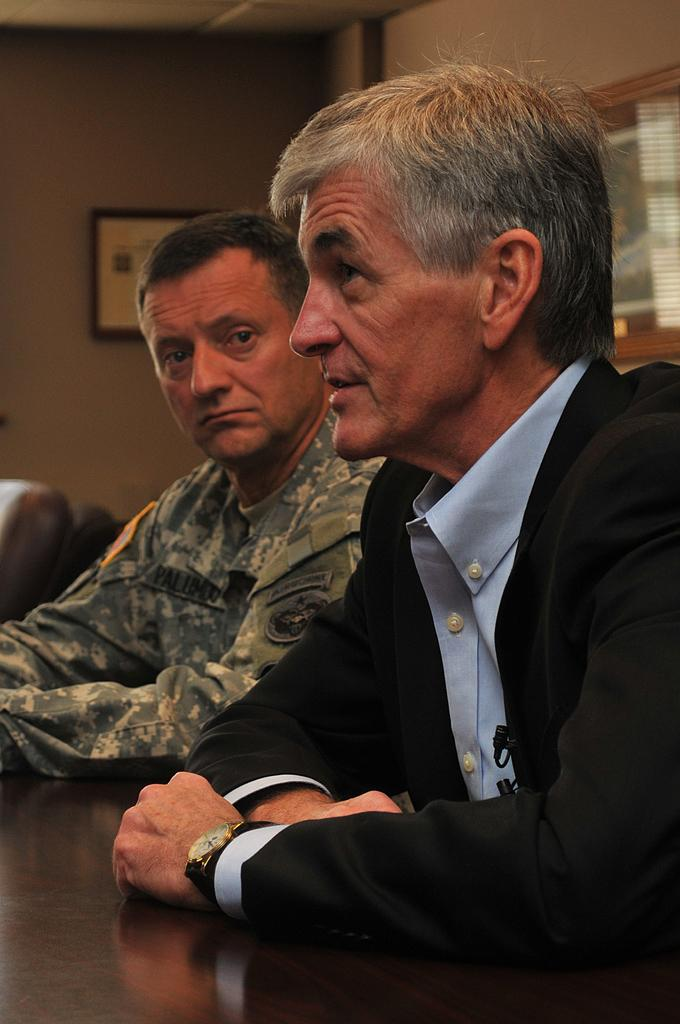How many people are in the image? There are two people in the image. What is the position of the person on the right side? The person on the right side is sitting. What is the person on the right side doing? The person on the right side is speaking. What is the position of the person on the left side? The person on the left side is sitting. What is the person on the left side doing? The person on the left side is listening. What type of trousers is the daughter wearing in the image? There is no daughter present in the image, and no mention of trousers. 